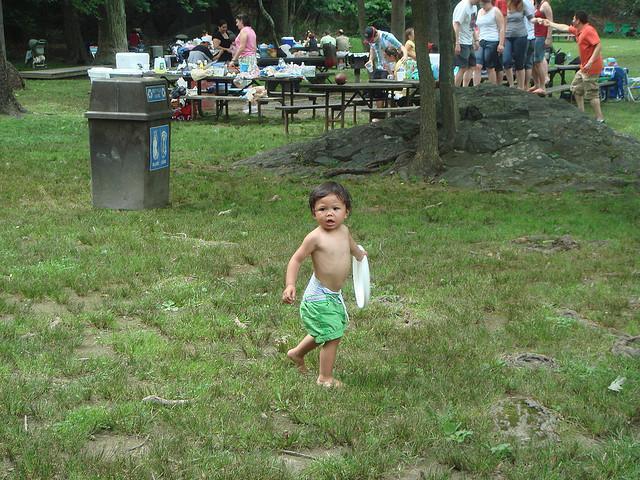How many people are there?
Give a very brief answer. 4. 